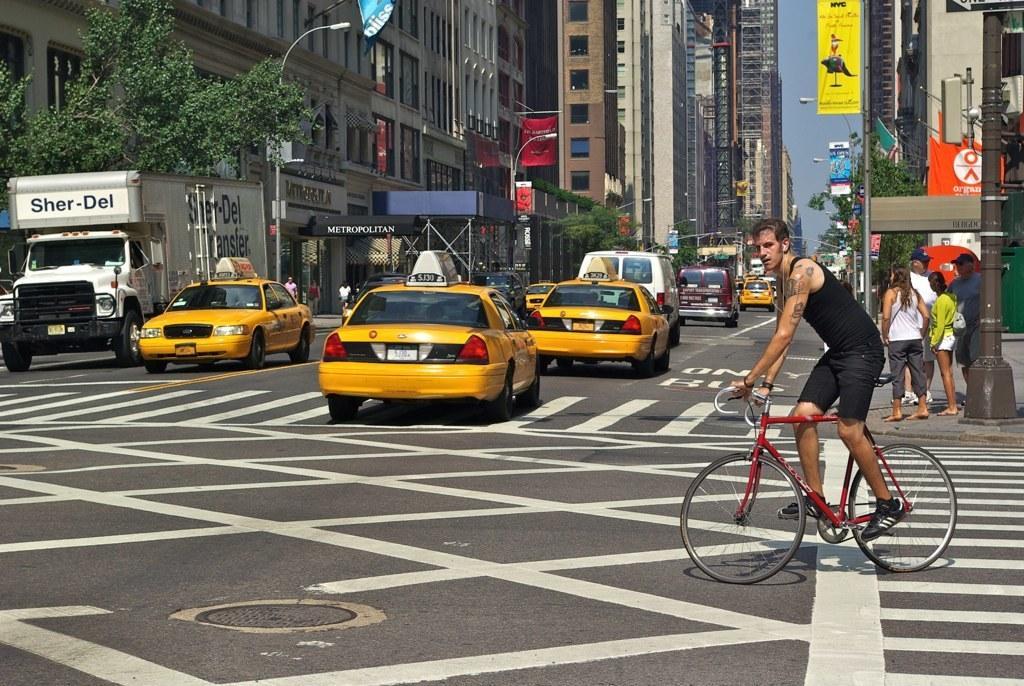Could you give a brief overview of what you see in this image? This picture is taken on the road side, In the right side there is a man riding a bicycle which is in red color, In the middle there are some cars which are in yellow color, In the right side there is a green color tree, In the background there are some buildings and in the right side there are some people walking. 